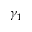<formula> <loc_0><loc_0><loc_500><loc_500>\gamma _ { 1 }</formula> 